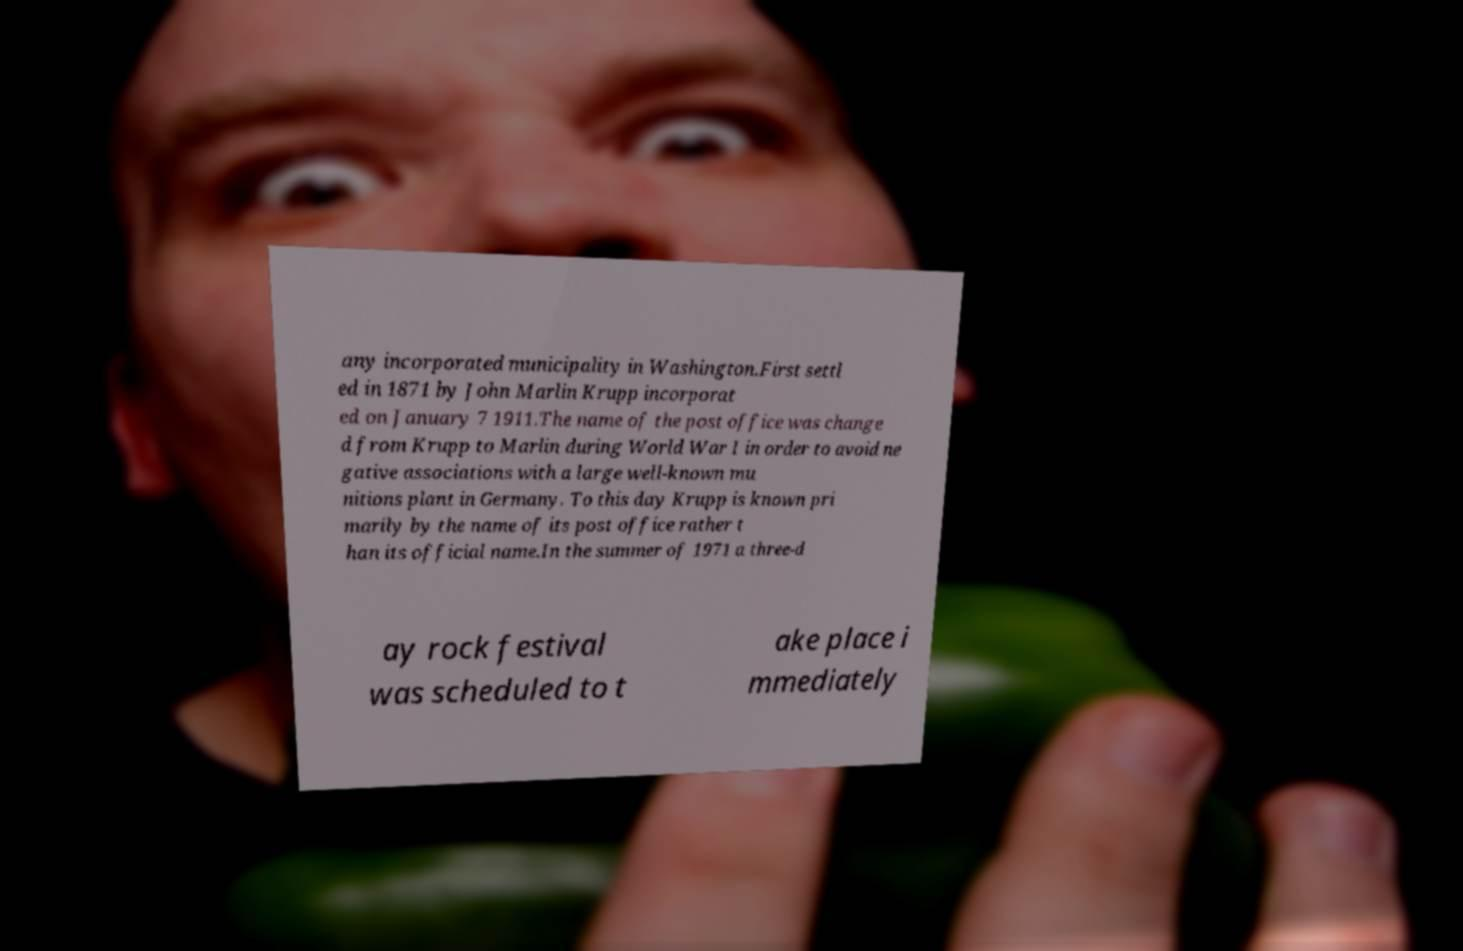Could you extract and type out the text from this image? any incorporated municipality in Washington.First settl ed in 1871 by John Marlin Krupp incorporat ed on January 7 1911.The name of the post office was change d from Krupp to Marlin during World War I in order to avoid ne gative associations with a large well-known mu nitions plant in Germany. To this day Krupp is known pri marily by the name of its post office rather t han its official name.In the summer of 1971 a three-d ay rock festival was scheduled to t ake place i mmediately 